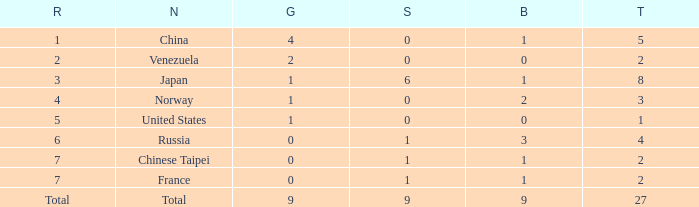What is the Nation when there is a total less than 27, gold is less than 1, and bronze is more than 1? Russia. 